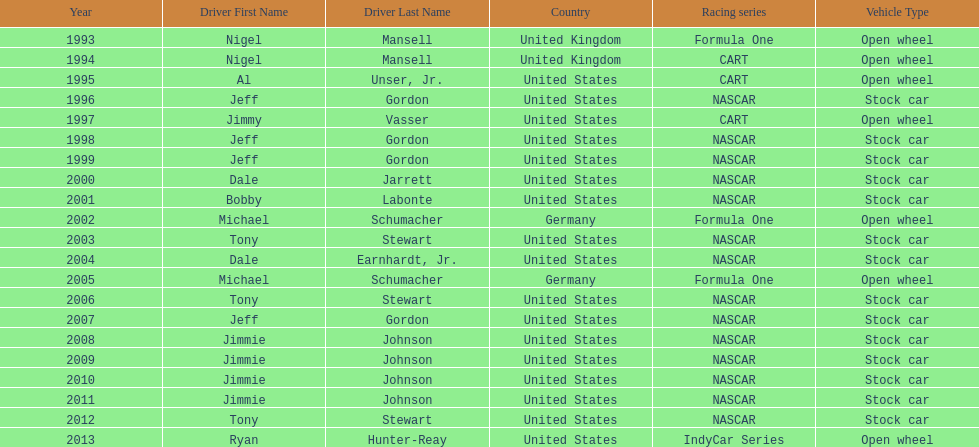Which racing series has the highest total of winners? NASCAR. 